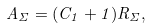<formula> <loc_0><loc_0><loc_500><loc_500>A _ { \Sigma } = ( C _ { 1 } + 1 ) R _ { \Sigma } ,</formula> 